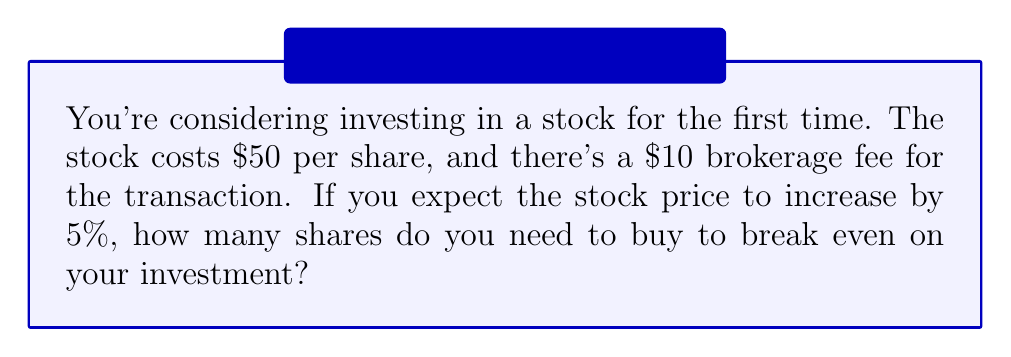Can you answer this question? Let's approach this step-by-step:

1) Let $x$ be the number of shares we need to buy.

2) The total cost of the investment is:
   $$ \text{Total Cost} = 50x + 10 $$

3) After a 5% increase, each share will be worth:
   $$ \text{New Price} = 50 \times 1.05 = 52.50 $$

4) The total value of the investment after the increase will be:
   $$ \text{New Value} = 52.50x $$

5) To break even, the New Value must equal the Total Cost:
   $$ 52.50x = 50x + 10 $$

6) Solving for $x$:
   $$ 52.50x - 50x = 10 $$
   $$ 2.50x = 10 $$
   $$ x = 10 \div 2.50 = 4 $$

7) Since we can't buy a fractional share, we need to round up to the nearest whole number.

Therefore, you need to buy 4 shares to break even.
Answer: 4 shares 